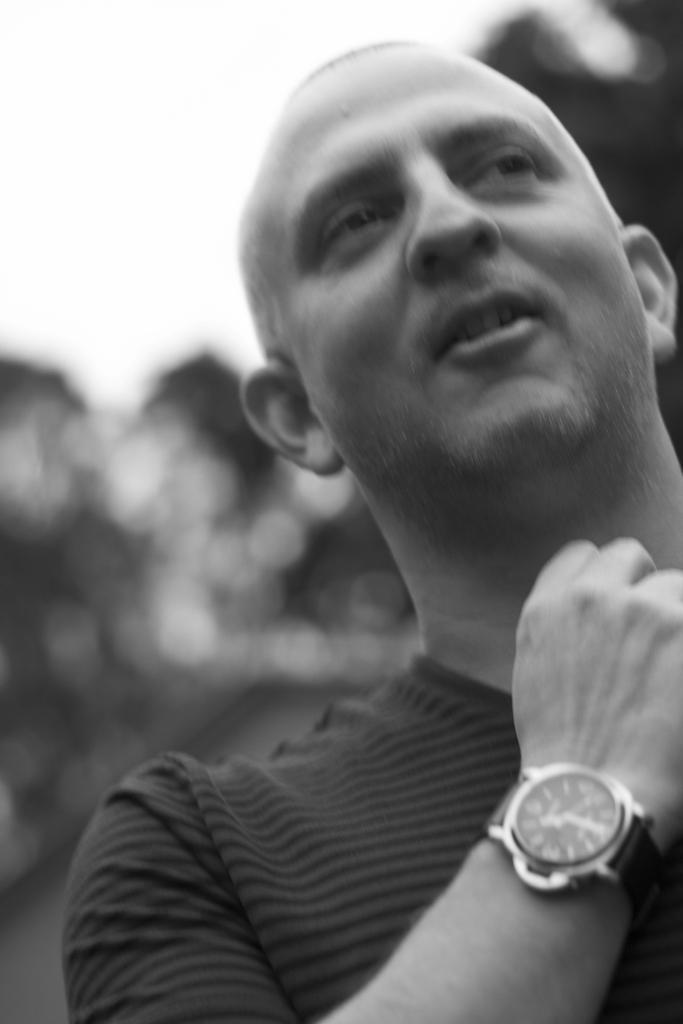Please provide a concise description of this image. In the image I can see a person who is wearing the watch and behind there are some trees. 